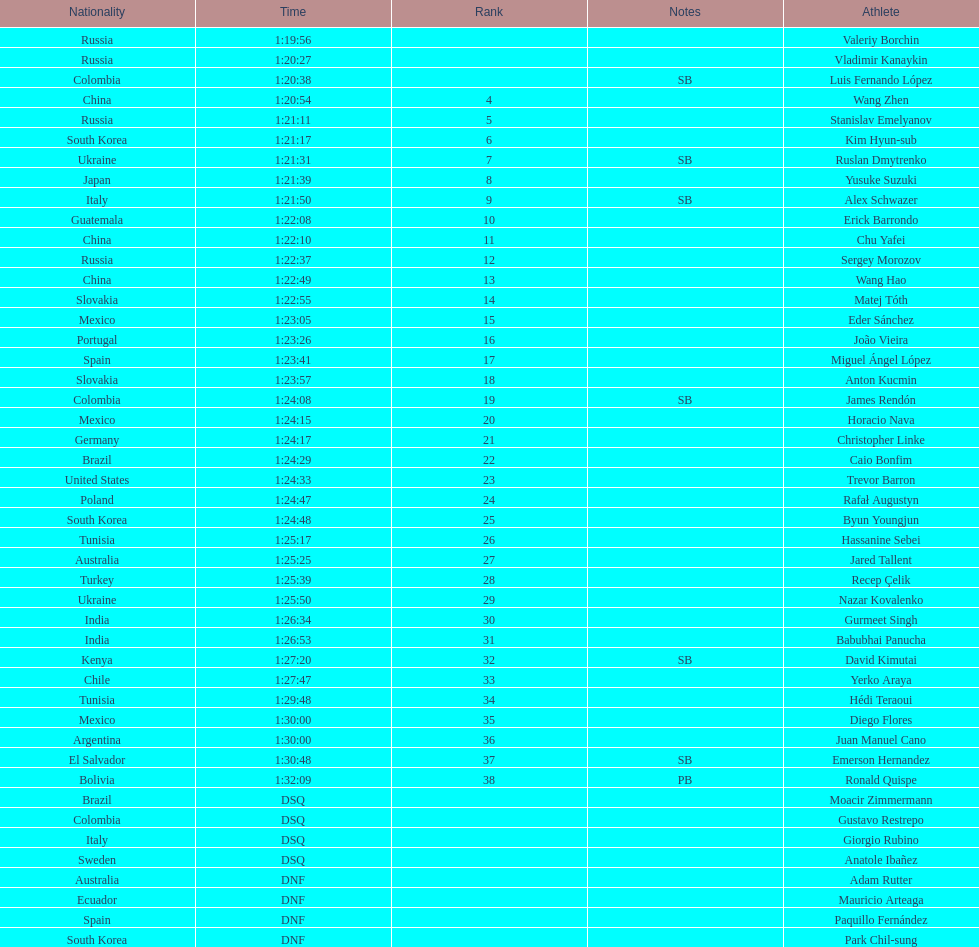Wang zhen and wang hao were both from which country? China. 